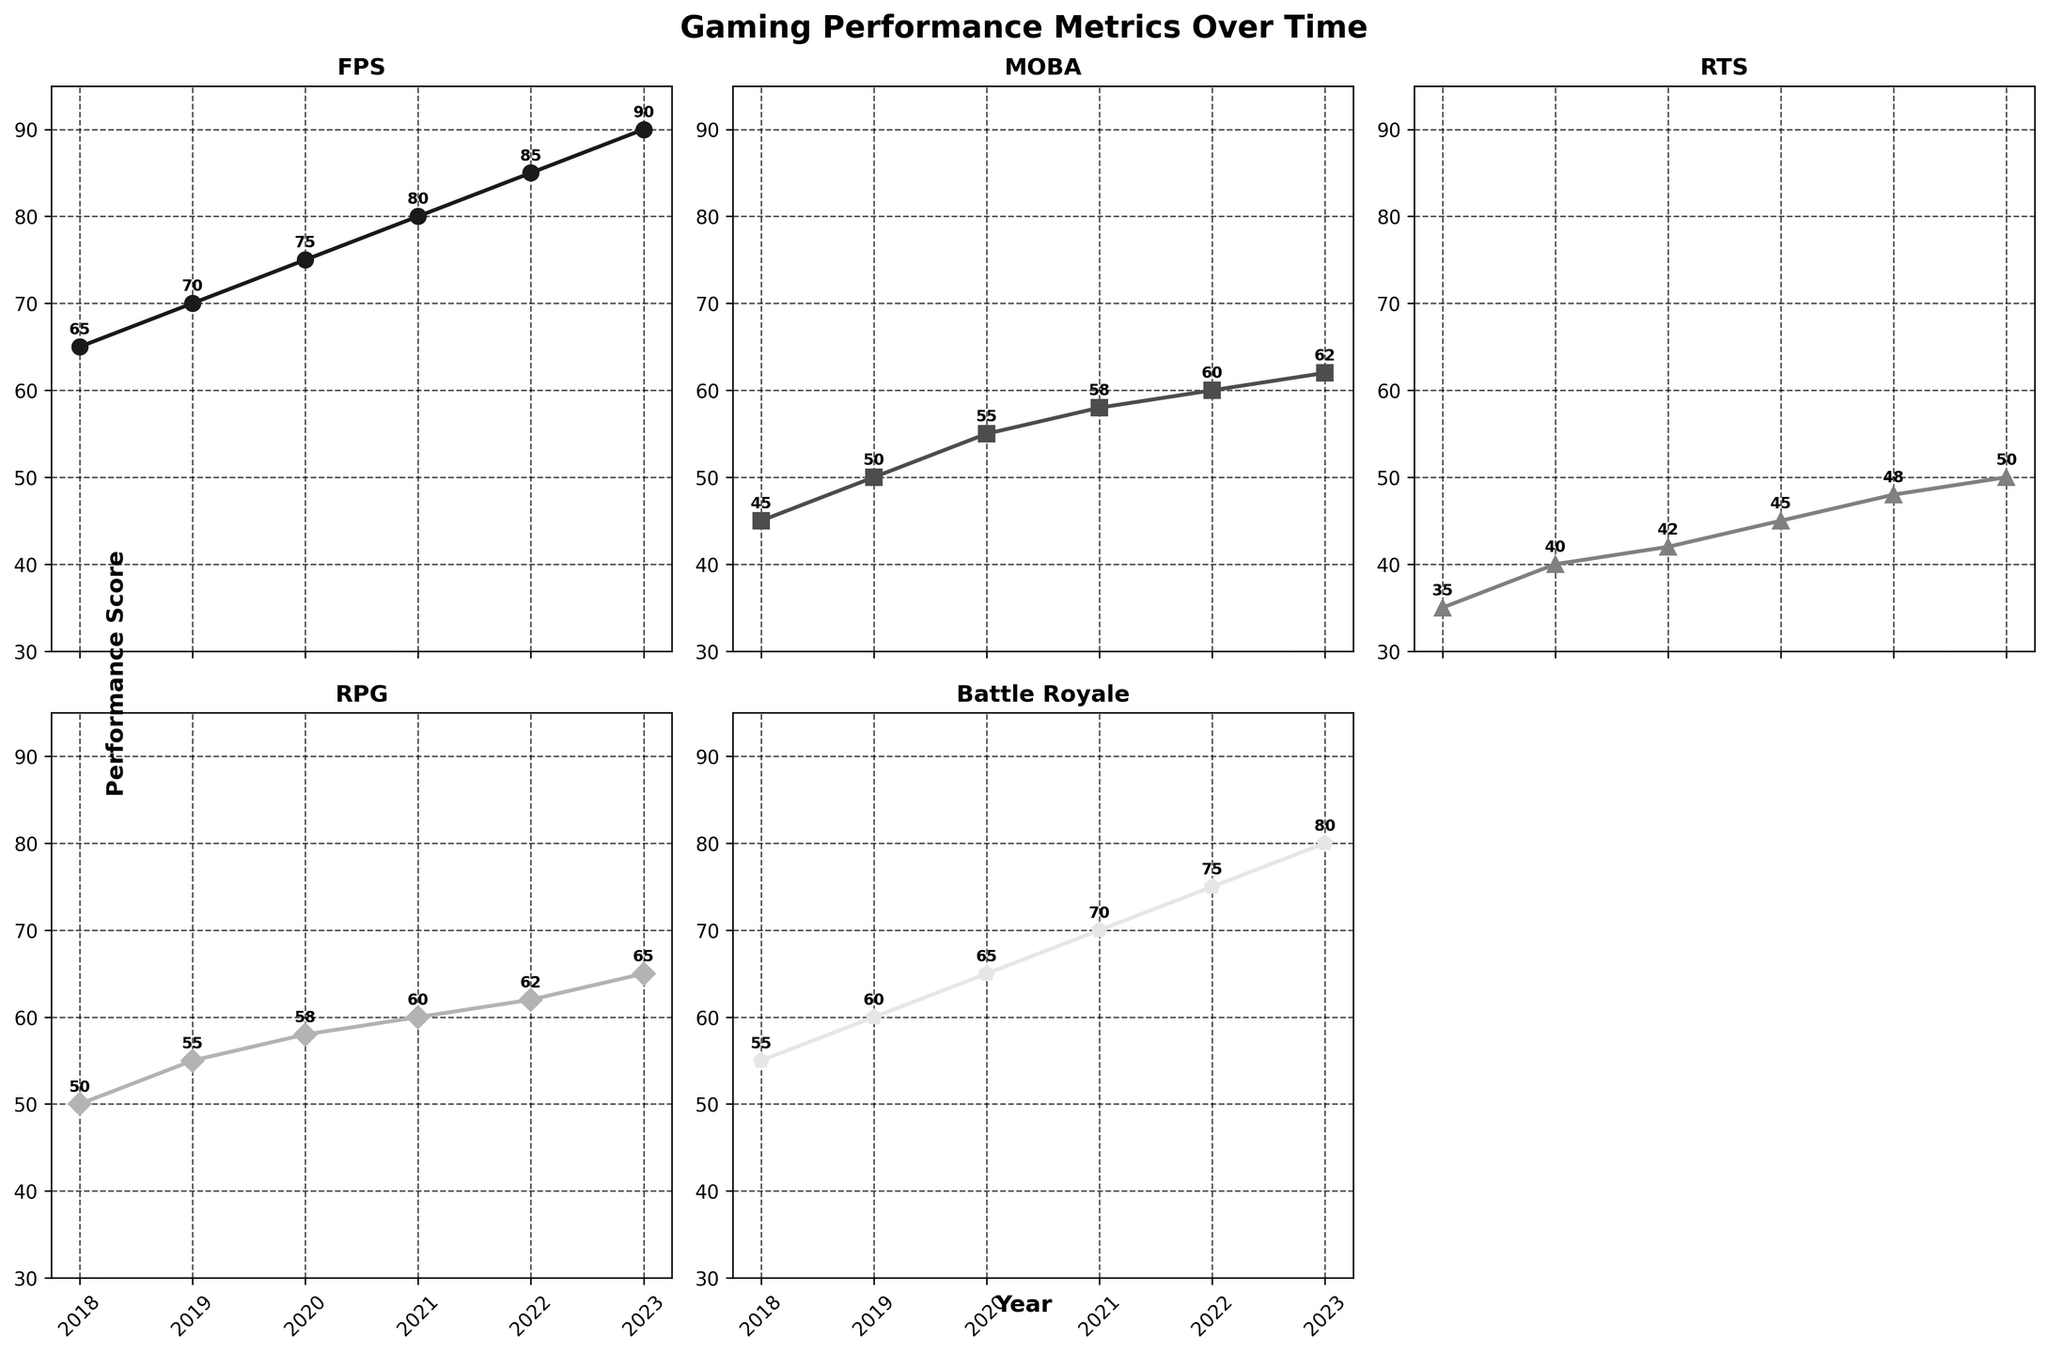What is the title of the figure? The title of the figure is located at the top of the plot. It's designed to give an overview of what the figure represents.
Answer: "Gaming Performance Metrics Over Time" Which genre had the highest performance score in 2023? To find this, look at the y-values for 2023 across all subplots, then identify the highest value. The FPS genre subplot shows the highest value of 90 in 2023.
Answer: FPS How much did the RPG performance score change from 2018 to 2023? Subtract the 2018 value from the 2023 value for the RPG. The values are 65 (2023) - 50 (2018) = 15.
Answer: 15 Which genre had the smallest increase in performance score between 2018 and 2023? Calculate the difference between 2018 and 2023 for each genre and find the smallest difference. The differences are:
FPS: 90 - 65 = 25
MOBA: 62 - 45 = 17
RTS: 50 - 35 = 15
RPG: 65 - 50 = 15
Battle Royale: 80 - 55 = 25
RTS and RPG have the smallest increase with 15 each.
Answer: RTS and RPG What is the average performance score of the MOBA genre over the years shown? Add the annual scores for MOBA and divide by the number of years. (45 + 50 + 55 + 58 + 60 + 62) / 6 = 330 / 6 = 55.
Answer: 55 Which two genres have performance scores closest to each other in 2023? Compare all the genres' 2023 values. The pairs and their differences:
FPS (90) and MOBA (62) = 28
FPS (90) and RTS (50) = 40
FPS (90) and RPG (65) = 25
FPS (90) and Battle Royale (80) = 10
MOBA (62) and RTS (50) = 12
MOBA (62) and RPG (65) = 3
MOBA (62) and Battle Royale (80) = 18
RTS (50) and RPG (65) = 15
RTS (50) and Battle Royale (80) = 30
RPG (65) and Battle Royale (80) = 15
The closest pair is MOBA and RPG with a difference of 3.
Answer: MOBA and RPG In which year did the Battle Royale genre surpass the RTS genre in performance score? Compare the performance scores of Battle Royale and RTS for each year. The crossover occurs when Battle Royale's score is higher than RTS's. This happens starting from 2019 with Battle Royale (60) surpassing RTS (40).
Answer: 2019 What is the median performance score of the FPS genre over the years shown? List the FPS scores in ascending order and find the middle value. For an even number of observations, average the two middle values.
The FPS scores are [65, 70, 75, 80, 85, 90]. The median is (75 + 80) / 2 = 155 / 2 = 77.5.
Answer: 77.5 Which genre showed the most consistent performance score increase over the years? Examine the lines in each subplot. The genre with the most uniform slope represents consistent growth. FPS shows a consistent linear increase without sudden jumps.
Answer: FPS 